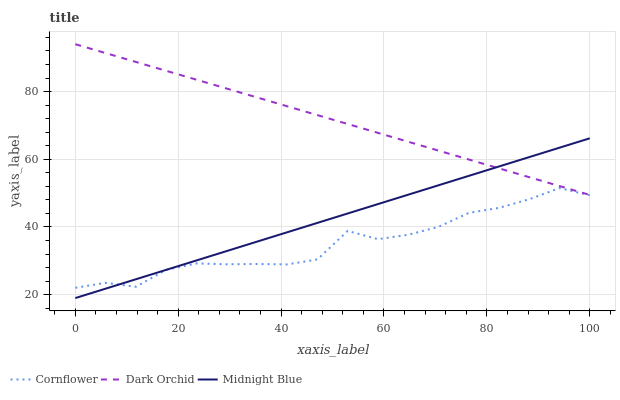Does Cornflower have the minimum area under the curve?
Answer yes or no. Yes. Does Dark Orchid have the maximum area under the curve?
Answer yes or no. Yes. Does Midnight Blue have the minimum area under the curve?
Answer yes or no. No. Does Midnight Blue have the maximum area under the curve?
Answer yes or no. No. Is Midnight Blue the smoothest?
Answer yes or no. Yes. Is Cornflower the roughest?
Answer yes or no. Yes. Is Dark Orchid the smoothest?
Answer yes or no. No. Is Dark Orchid the roughest?
Answer yes or no. No. Does Midnight Blue have the lowest value?
Answer yes or no. Yes. Does Dark Orchid have the lowest value?
Answer yes or no. No. Does Dark Orchid have the highest value?
Answer yes or no. Yes. Does Midnight Blue have the highest value?
Answer yes or no. No. Is Cornflower less than Dark Orchid?
Answer yes or no. Yes. Is Dark Orchid greater than Cornflower?
Answer yes or no. Yes. Does Dark Orchid intersect Midnight Blue?
Answer yes or no. Yes. Is Dark Orchid less than Midnight Blue?
Answer yes or no. No. Is Dark Orchid greater than Midnight Blue?
Answer yes or no. No. Does Cornflower intersect Dark Orchid?
Answer yes or no. No. 